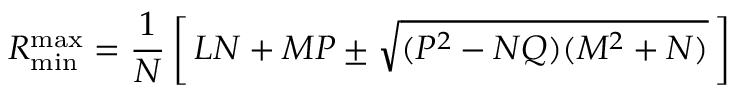<formula> <loc_0><loc_0><loc_500><loc_500>R _ { \min } ^ { \max } = \frac { 1 } { N } \left [ \, L N + M P \pm \sqrt { ( P ^ { 2 } - N Q ) ( M ^ { 2 } + N ) } \, \right ]</formula> 